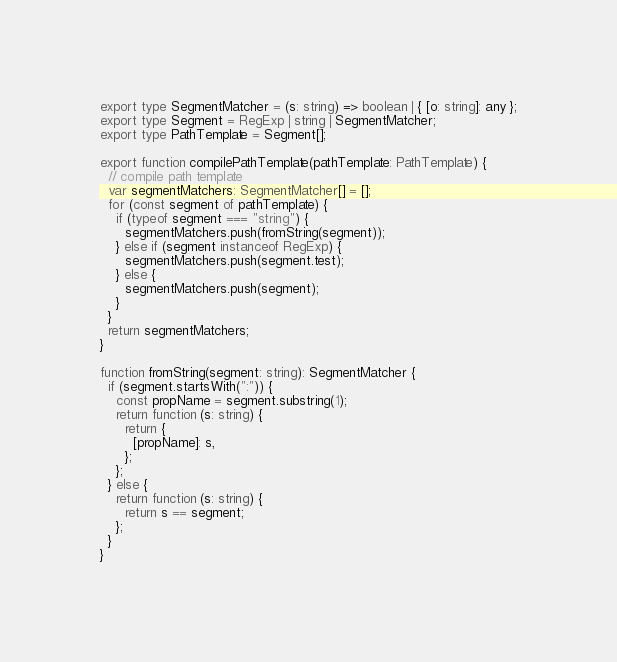<code> <loc_0><loc_0><loc_500><loc_500><_TypeScript_>export type SegmentMatcher = (s: string) => boolean | { [o: string]: any };
export type Segment = RegExp | string | SegmentMatcher;
export type PathTemplate = Segment[];

export function compilePathTemplate(pathTemplate: PathTemplate) {
  // compile path template
  var segmentMatchers: SegmentMatcher[] = [];
  for (const segment of pathTemplate) {
    if (typeof segment === "string") {
      segmentMatchers.push(fromString(segment));
    } else if (segment instanceof RegExp) {
      segmentMatchers.push(segment.test);
    } else {
      segmentMatchers.push(segment);
    }
  }
  return segmentMatchers;
}

function fromString(segment: string): SegmentMatcher {
  if (segment.startsWith(":")) {
    const propName = segment.substring(1);
    return function (s: string) {
      return {
        [propName]: s,
      };
    };
  } else {
    return function (s: string) {
      return s == segment;
    };
  }
}
</code> 